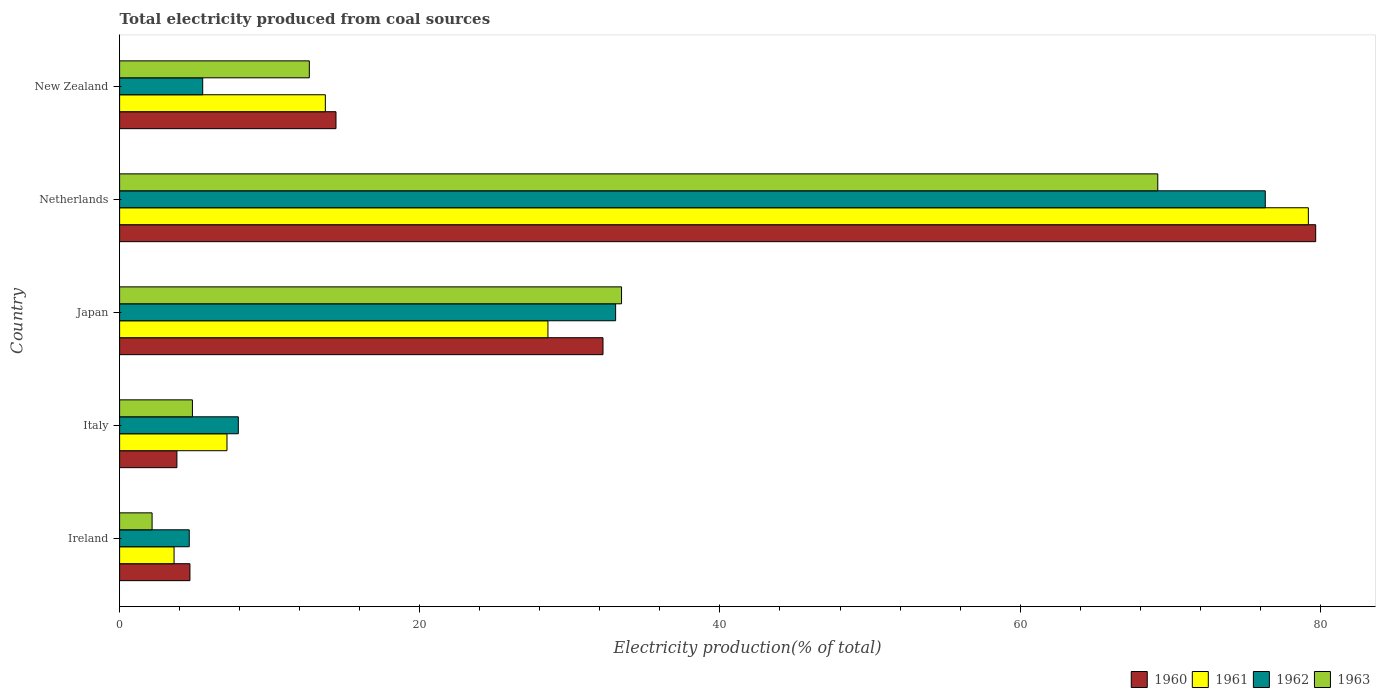How many different coloured bars are there?
Keep it short and to the point. 4. How many groups of bars are there?
Provide a short and direct response. 5. How many bars are there on the 5th tick from the top?
Provide a short and direct response. 4. How many bars are there on the 2nd tick from the bottom?
Offer a terse response. 4. What is the label of the 1st group of bars from the top?
Offer a terse response. New Zealand. In how many cases, is the number of bars for a given country not equal to the number of legend labels?
Ensure brevity in your answer.  0. What is the total electricity produced in 1960 in Ireland?
Your answer should be compact. 4.69. Across all countries, what is the maximum total electricity produced in 1961?
Ensure brevity in your answer.  79.2. Across all countries, what is the minimum total electricity produced in 1961?
Make the answer very short. 3.63. In which country was the total electricity produced in 1960 minimum?
Your answer should be very brief. Italy. What is the total total electricity produced in 1963 in the graph?
Your answer should be very brief. 122.27. What is the difference between the total electricity produced in 1960 in Ireland and that in New Zealand?
Keep it short and to the point. -9.73. What is the difference between the total electricity produced in 1963 in Italy and the total electricity produced in 1960 in New Zealand?
Give a very brief answer. -9.56. What is the average total electricity produced in 1963 per country?
Offer a terse response. 24.45. What is the difference between the total electricity produced in 1960 and total electricity produced in 1962 in Ireland?
Give a very brief answer. 0.05. In how many countries, is the total electricity produced in 1962 greater than 12 %?
Offer a terse response. 2. What is the ratio of the total electricity produced in 1962 in Italy to that in New Zealand?
Your response must be concise. 1.43. Is the difference between the total electricity produced in 1960 in Ireland and Italy greater than the difference between the total electricity produced in 1962 in Ireland and Italy?
Your answer should be compact. Yes. What is the difference between the highest and the second highest total electricity produced in 1960?
Provide a short and direct response. 47.48. What is the difference between the highest and the lowest total electricity produced in 1962?
Your answer should be compact. 71.69. Is the sum of the total electricity produced in 1963 in Ireland and New Zealand greater than the maximum total electricity produced in 1960 across all countries?
Your response must be concise. No. Is it the case that in every country, the sum of the total electricity produced in 1961 and total electricity produced in 1963 is greater than the sum of total electricity produced in 1960 and total electricity produced in 1962?
Provide a succinct answer. No. Is it the case that in every country, the sum of the total electricity produced in 1962 and total electricity produced in 1960 is greater than the total electricity produced in 1963?
Make the answer very short. Yes. Are all the bars in the graph horizontal?
Give a very brief answer. Yes. Are the values on the major ticks of X-axis written in scientific E-notation?
Your answer should be very brief. No. How are the legend labels stacked?
Offer a terse response. Horizontal. What is the title of the graph?
Provide a short and direct response. Total electricity produced from coal sources. Does "1997" appear as one of the legend labels in the graph?
Your answer should be very brief. No. What is the label or title of the X-axis?
Your answer should be very brief. Electricity production(% of total). What is the Electricity production(% of total) of 1960 in Ireland?
Offer a terse response. 4.69. What is the Electricity production(% of total) of 1961 in Ireland?
Your response must be concise. 3.63. What is the Electricity production(% of total) of 1962 in Ireland?
Offer a very short reply. 4.64. What is the Electricity production(% of total) of 1963 in Ireland?
Make the answer very short. 2.16. What is the Electricity production(% of total) of 1960 in Italy?
Provide a succinct answer. 3.82. What is the Electricity production(% of total) of 1961 in Italy?
Offer a terse response. 7.15. What is the Electricity production(% of total) of 1962 in Italy?
Provide a short and direct response. 7.91. What is the Electricity production(% of total) in 1963 in Italy?
Offer a very short reply. 4.85. What is the Electricity production(% of total) of 1960 in Japan?
Offer a very short reply. 32.21. What is the Electricity production(% of total) of 1961 in Japan?
Ensure brevity in your answer.  28.54. What is the Electricity production(% of total) in 1962 in Japan?
Make the answer very short. 33.05. What is the Electricity production(% of total) of 1963 in Japan?
Provide a succinct answer. 33.44. What is the Electricity production(% of total) of 1960 in Netherlands?
Make the answer very short. 79.69. What is the Electricity production(% of total) in 1961 in Netherlands?
Your response must be concise. 79.2. What is the Electricity production(% of total) of 1962 in Netherlands?
Ensure brevity in your answer.  76.33. What is the Electricity production(% of total) in 1963 in Netherlands?
Make the answer very short. 69.17. What is the Electricity production(% of total) of 1960 in New Zealand?
Offer a very short reply. 14.42. What is the Electricity production(% of total) in 1961 in New Zealand?
Your answer should be very brief. 13.71. What is the Electricity production(% of total) of 1962 in New Zealand?
Offer a terse response. 5.54. What is the Electricity production(% of total) in 1963 in New Zealand?
Your answer should be very brief. 12.64. Across all countries, what is the maximum Electricity production(% of total) in 1960?
Provide a succinct answer. 79.69. Across all countries, what is the maximum Electricity production(% of total) of 1961?
Your answer should be compact. 79.2. Across all countries, what is the maximum Electricity production(% of total) in 1962?
Provide a short and direct response. 76.33. Across all countries, what is the maximum Electricity production(% of total) in 1963?
Offer a very short reply. 69.17. Across all countries, what is the minimum Electricity production(% of total) of 1960?
Provide a succinct answer. 3.82. Across all countries, what is the minimum Electricity production(% of total) in 1961?
Keep it short and to the point. 3.63. Across all countries, what is the minimum Electricity production(% of total) in 1962?
Your answer should be very brief. 4.64. Across all countries, what is the minimum Electricity production(% of total) in 1963?
Offer a very short reply. 2.16. What is the total Electricity production(% of total) of 1960 in the graph?
Your answer should be compact. 134.82. What is the total Electricity production(% of total) of 1961 in the graph?
Your answer should be compact. 132.23. What is the total Electricity production(% of total) in 1962 in the graph?
Offer a terse response. 127.47. What is the total Electricity production(% of total) in 1963 in the graph?
Your response must be concise. 122.27. What is the difference between the Electricity production(% of total) of 1960 in Ireland and that in Italy?
Your response must be concise. 0.87. What is the difference between the Electricity production(% of total) of 1961 in Ireland and that in Italy?
Keep it short and to the point. -3.53. What is the difference between the Electricity production(% of total) of 1962 in Ireland and that in Italy?
Ensure brevity in your answer.  -3.27. What is the difference between the Electricity production(% of total) of 1963 in Ireland and that in Italy?
Ensure brevity in your answer.  -2.69. What is the difference between the Electricity production(% of total) of 1960 in Ireland and that in Japan?
Your answer should be very brief. -27.52. What is the difference between the Electricity production(% of total) in 1961 in Ireland and that in Japan?
Ensure brevity in your answer.  -24.91. What is the difference between the Electricity production(% of total) in 1962 in Ireland and that in Japan?
Keep it short and to the point. -28.41. What is the difference between the Electricity production(% of total) of 1963 in Ireland and that in Japan?
Give a very brief answer. -31.28. What is the difference between the Electricity production(% of total) in 1960 in Ireland and that in Netherlands?
Offer a terse response. -75.01. What is the difference between the Electricity production(% of total) of 1961 in Ireland and that in Netherlands?
Provide a short and direct response. -75.58. What is the difference between the Electricity production(% of total) in 1962 in Ireland and that in Netherlands?
Your response must be concise. -71.69. What is the difference between the Electricity production(% of total) of 1963 in Ireland and that in Netherlands?
Your response must be concise. -67.01. What is the difference between the Electricity production(% of total) of 1960 in Ireland and that in New Zealand?
Make the answer very short. -9.73. What is the difference between the Electricity production(% of total) of 1961 in Ireland and that in New Zealand?
Give a very brief answer. -10.08. What is the difference between the Electricity production(% of total) in 1962 in Ireland and that in New Zealand?
Give a very brief answer. -0.9. What is the difference between the Electricity production(% of total) in 1963 in Ireland and that in New Zealand?
Your response must be concise. -10.48. What is the difference between the Electricity production(% of total) in 1960 in Italy and that in Japan?
Provide a short and direct response. -28.39. What is the difference between the Electricity production(% of total) of 1961 in Italy and that in Japan?
Ensure brevity in your answer.  -21.38. What is the difference between the Electricity production(% of total) in 1962 in Italy and that in Japan?
Your response must be concise. -25.14. What is the difference between the Electricity production(% of total) of 1963 in Italy and that in Japan?
Keep it short and to the point. -28.59. What is the difference between the Electricity production(% of total) of 1960 in Italy and that in Netherlands?
Make the answer very short. -75.87. What is the difference between the Electricity production(% of total) in 1961 in Italy and that in Netherlands?
Your response must be concise. -72.05. What is the difference between the Electricity production(% of total) of 1962 in Italy and that in Netherlands?
Give a very brief answer. -68.42. What is the difference between the Electricity production(% of total) in 1963 in Italy and that in Netherlands?
Offer a terse response. -64.32. What is the difference between the Electricity production(% of total) of 1960 in Italy and that in New Zealand?
Your response must be concise. -10.6. What is the difference between the Electricity production(% of total) of 1961 in Italy and that in New Zealand?
Offer a very short reply. -6.55. What is the difference between the Electricity production(% of total) in 1962 in Italy and that in New Zealand?
Give a very brief answer. 2.37. What is the difference between the Electricity production(% of total) in 1963 in Italy and that in New Zealand?
Offer a terse response. -7.79. What is the difference between the Electricity production(% of total) in 1960 in Japan and that in Netherlands?
Offer a terse response. -47.48. What is the difference between the Electricity production(% of total) in 1961 in Japan and that in Netherlands?
Give a very brief answer. -50.67. What is the difference between the Electricity production(% of total) in 1962 in Japan and that in Netherlands?
Make the answer very short. -43.28. What is the difference between the Electricity production(% of total) of 1963 in Japan and that in Netherlands?
Provide a short and direct response. -35.73. What is the difference between the Electricity production(% of total) in 1960 in Japan and that in New Zealand?
Provide a succinct answer. 17.79. What is the difference between the Electricity production(% of total) of 1961 in Japan and that in New Zealand?
Keep it short and to the point. 14.83. What is the difference between the Electricity production(% of total) of 1962 in Japan and that in New Zealand?
Give a very brief answer. 27.51. What is the difference between the Electricity production(% of total) in 1963 in Japan and that in New Zealand?
Offer a very short reply. 20.8. What is the difference between the Electricity production(% of total) of 1960 in Netherlands and that in New Zealand?
Your answer should be very brief. 65.28. What is the difference between the Electricity production(% of total) of 1961 in Netherlands and that in New Zealand?
Your response must be concise. 65.5. What is the difference between the Electricity production(% of total) in 1962 in Netherlands and that in New Zealand?
Your response must be concise. 70.8. What is the difference between the Electricity production(% of total) in 1963 in Netherlands and that in New Zealand?
Give a very brief answer. 56.53. What is the difference between the Electricity production(% of total) in 1960 in Ireland and the Electricity production(% of total) in 1961 in Italy?
Your response must be concise. -2.47. What is the difference between the Electricity production(% of total) of 1960 in Ireland and the Electricity production(% of total) of 1962 in Italy?
Give a very brief answer. -3.22. What is the difference between the Electricity production(% of total) in 1960 in Ireland and the Electricity production(% of total) in 1963 in Italy?
Offer a terse response. -0.17. What is the difference between the Electricity production(% of total) of 1961 in Ireland and the Electricity production(% of total) of 1962 in Italy?
Provide a succinct answer. -4.28. What is the difference between the Electricity production(% of total) in 1961 in Ireland and the Electricity production(% of total) in 1963 in Italy?
Provide a short and direct response. -1.22. What is the difference between the Electricity production(% of total) in 1962 in Ireland and the Electricity production(% of total) in 1963 in Italy?
Your answer should be very brief. -0.21. What is the difference between the Electricity production(% of total) of 1960 in Ireland and the Electricity production(% of total) of 1961 in Japan?
Your answer should be very brief. -23.85. What is the difference between the Electricity production(% of total) of 1960 in Ireland and the Electricity production(% of total) of 1962 in Japan?
Offer a terse response. -28.36. What is the difference between the Electricity production(% of total) of 1960 in Ireland and the Electricity production(% of total) of 1963 in Japan?
Give a very brief answer. -28.76. What is the difference between the Electricity production(% of total) in 1961 in Ireland and the Electricity production(% of total) in 1962 in Japan?
Ensure brevity in your answer.  -29.42. What is the difference between the Electricity production(% of total) in 1961 in Ireland and the Electricity production(% of total) in 1963 in Japan?
Offer a terse response. -29.82. What is the difference between the Electricity production(% of total) of 1962 in Ireland and the Electricity production(% of total) of 1963 in Japan?
Make the answer very short. -28.8. What is the difference between the Electricity production(% of total) of 1960 in Ireland and the Electricity production(% of total) of 1961 in Netherlands?
Offer a very short reply. -74.52. What is the difference between the Electricity production(% of total) of 1960 in Ireland and the Electricity production(% of total) of 1962 in Netherlands?
Provide a succinct answer. -71.65. What is the difference between the Electricity production(% of total) in 1960 in Ireland and the Electricity production(% of total) in 1963 in Netherlands?
Ensure brevity in your answer.  -64.49. What is the difference between the Electricity production(% of total) in 1961 in Ireland and the Electricity production(% of total) in 1962 in Netherlands?
Your answer should be compact. -72.71. What is the difference between the Electricity production(% of total) of 1961 in Ireland and the Electricity production(% of total) of 1963 in Netherlands?
Ensure brevity in your answer.  -65.54. What is the difference between the Electricity production(% of total) in 1962 in Ireland and the Electricity production(% of total) in 1963 in Netherlands?
Provide a short and direct response. -64.53. What is the difference between the Electricity production(% of total) of 1960 in Ireland and the Electricity production(% of total) of 1961 in New Zealand?
Make the answer very short. -9.02. What is the difference between the Electricity production(% of total) of 1960 in Ireland and the Electricity production(% of total) of 1962 in New Zealand?
Offer a very short reply. -0.85. What is the difference between the Electricity production(% of total) of 1960 in Ireland and the Electricity production(% of total) of 1963 in New Zealand?
Give a very brief answer. -7.95. What is the difference between the Electricity production(% of total) in 1961 in Ireland and the Electricity production(% of total) in 1962 in New Zealand?
Ensure brevity in your answer.  -1.91. What is the difference between the Electricity production(% of total) in 1961 in Ireland and the Electricity production(% of total) in 1963 in New Zealand?
Make the answer very short. -9.01. What is the difference between the Electricity production(% of total) of 1962 in Ireland and the Electricity production(% of total) of 1963 in New Zealand?
Your response must be concise. -8. What is the difference between the Electricity production(% of total) of 1960 in Italy and the Electricity production(% of total) of 1961 in Japan?
Ensure brevity in your answer.  -24.72. What is the difference between the Electricity production(% of total) in 1960 in Italy and the Electricity production(% of total) in 1962 in Japan?
Your response must be concise. -29.23. What is the difference between the Electricity production(% of total) of 1960 in Italy and the Electricity production(% of total) of 1963 in Japan?
Provide a short and direct response. -29.63. What is the difference between the Electricity production(% of total) of 1961 in Italy and the Electricity production(% of total) of 1962 in Japan?
Make the answer very short. -25.89. What is the difference between the Electricity production(% of total) of 1961 in Italy and the Electricity production(% of total) of 1963 in Japan?
Your answer should be very brief. -26.29. What is the difference between the Electricity production(% of total) of 1962 in Italy and the Electricity production(% of total) of 1963 in Japan?
Provide a short and direct response. -25.53. What is the difference between the Electricity production(% of total) in 1960 in Italy and the Electricity production(% of total) in 1961 in Netherlands?
Provide a succinct answer. -75.39. What is the difference between the Electricity production(% of total) in 1960 in Italy and the Electricity production(% of total) in 1962 in Netherlands?
Your answer should be very brief. -72.51. What is the difference between the Electricity production(% of total) of 1960 in Italy and the Electricity production(% of total) of 1963 in Netherlands?
Offer a terse response. -65.35. What is the difference between the Electricity production(% of total) in 1961 in Italy and the Electricity production(% of total) in 1962 in Netherlands?
Your answer should be very brief. -69.18. What is the difference between the Electricity production(% of total) in 1961 in Italy and the Electricity production(% of total) in 1963 in Netherlands?
Make the answer very short. -62.02. What is the difference between the Electricity production(% of total) in 1962 in Italy and the Electricity production(% of total) in 1963 in Netherlands?
Make the answer very short. -61.26. What is the difference between the Electricity production(% of total) in 1960 in Italy and the Electricity production(% of total) in 1961 in New Zealand?
Provide a short and direct response. -9.89. What is the difference between the Electricity production(% of total) in 1960 in Italy and the Electricity production(% of total) in 1962 in New Zealand?
Offer a terse response. -1.72. What is the difference between the Electricity production(% of total) of 1960 in Italy and the Electricity production(% of total) of 1963 in New Zealand?
Ensure brevity in your answer.  -8.82. What is the difference between the Electricity production(% of total) of 1961 in Italy and the Electricity production(% of total) of 1962 in New Zealand?
Provide a short and direct response. 1.62. What is the difference between the Electricity production(% of total) of 1961 in Italy and the Electricity production(% of total) of 1963 in New Zealand?
Make the answer very short. -5.49. What is the difference between the Electricity production(% of total) of 1962 in Italy and the Electricity production(% of total) of 1963 in New Zealand?
Your response must be concise. -4.73. What is the difference between the Electricity production(% of total) in 1960 in Japan and the Electricity production(% of total) in 1961 in Netherlands?
Your answer should be compact. -47. What is the difference between the Electricity production(% of total) of 1960 in Japan and the Electricity production(% of total) of 1962 in Netherlands?
Make the answer very short. -44.13. What is the difference between the Electricity production(% of total) of 1960 in Japan and the Electricity production(% of total) of 1963 in Netherlands?
Your response must be concise. -36.96. What is the difference between the Electricity production(% of total) in 1961 in Japan and the Electricity production(% of total) in 1962 in Netherlands?
Your answer should be very brief. -47.79. What is the difference between the Electricity production(% of total) of 1961 in Japan and the Electricity production(% of total) of 1963 in Netherlands?
Your answer should be compact. -40.63. What is the difference between the Electricity production(% of total) of 1962 in Japan and the Electricity production(% of total) of 1963 in Netherlands?
Provide a succinct answer. -36.12. What is the difference between the Electricity production(% of total) of 1960 in Japan and the Electricity production(% of total) of 1961 in New Zealand?
Keep it short and to the point. 18.5. What is the difference between the Electricity production(% of total) of 1960 in Japan and the Electricity production(% of total) of 1962 in New Zealand?
Your answer should be compact. 26.67. What is the difference between the Electricity production(% of total) of 1960 in Japan and the Electricity production(% of total) of 1963 in New Zealand?
Provide a short and direct response. 19.57. What is the difference between the Electricity production(% of total) of 1961 in Japan and the Electricity production(% of total) of 1962 in New Zealand?
Your response must be concise. 23. What is the difference between the Electricity production(% of total) in 1961 in Japan and the Electricity production(% of total) in 1963 in New Zealand?
Ensure brevity in your answer.  15.9. What is the difference between the Electricity production(% of total) of 1962 in Japan and the Electricity production(% of total) of 1963 in New Zealand?
Make the answer very short. 20.41. What is the difference between the Electricity production(% of total) of 1960 in Netherlands and the Electricity production(% of total) of 1961 in New Zealand?
Give a very brief answer. 65.98. What is the difference between the Electricity production(% of total) in 1960 in Netherlands and the Electricity production(% of total) in 1962 in New Zealand?
Your response must be concise. 74.16. What is the difference between the Electricity production(% of total) of 1960 in Netherlands and the Electricity production(% of total) of 1963 in New Zealand?
Keep it short and to the point. 67.05. What is the difference between the Electricity production(% of total) in 1961 in Netherlands and the Electricity production(% of total) in 1962 in New Zealand?
Your answer should be very brief. 73.67. What is the difference between the Electricity production(% of total) of 1961 in Netherlands and the Electricity production(% of total) of 1963 in New Zealand?
Your answer should be compact. 66.56. What is the difference between the Electricity production(% of total) in 1962 in Netherlands and the Electricity production(% of total) in 1963 in New Zealand?
Provide a succinct answer. 63.69. What is the average Electricity production(% of total) of 1960 per country?
Keep it short and to the point. 26.96. What is the average Electricity production(% of total) of 1961 per country?
Ensure brevity in your answer.  26.45. What is the average Electricity production(% of total) of 1962 per country?
Your answer should be very brief. 25.49. What is the average Electricity production(% of total) of 1963 per country?
Your answer should be compact. 24.45. What is the difference between the Electricity production(% of total) of 1960 and Electricity production(% of total) of 1961 in Ireland?
Your response must be concise. 1.06. What is the difference between the Electricity production(% of total) in 1960 and Electricity production(% of total) in 1962 in Ireland?
Your answer should be very brief. 0.05. What is the difference between the Electricity production(% of total) of 1960 and Electricity production(% of total) of 1963 in Ireland?
Provide a short and direct response. 2.52. What is the difference between the Electricity production(% of total) of 1961 and Electricity production(% of total) of 1962 in Ireland?
Provide a succinct answer. -1.01. What is the difference between the Electricity production(% of total) of 1961 and Electricity production(% of total) of 1963 in Ireland?
Provide a succinct answer. 1.46. What is the difference between the Electricity production(% of total) of 1962 and Electricity production(% of total) of 1963 in Ireland?
Give a very brief answer. 2.48. What is the difference between the Electricity production(% of total) of 1960 and Electricity production(% of total) of 1961 in Italy?
Provide a succinct answer. -3.34. What is the difference between the Electricity production(% of total) of 1960 and Electricity production(% of total) of 1962 in Italy?
Keep it short and to the point. -4.09. What is the difference between the Electricity production(% of total) of 1960 and Electricity production(% of total) of 1963 in Italy?
Your answer should be very brief. -1.03. What is the difference between the Electricity production(% of total) of 1961 and Electricity production(% of total) of 1962 in Italy?
Keep it short and to the point. -0.75. What is the difference between the Electricity production(% of total) in 1961 and Electricity production(% of total) in 1963 in Italy?
Ensure brevity in your answer.  2.3. What is the difference between the Electricity production(% of total) in 1962 and Electricity production(% of total) in 1963 in Italy?
Make the answer very short. 3.06. What is the difference between the Electricity production(% of total) of 1960 and Electricity production(% of total) of 1961 in Japan?
Offer a terse response. 3.67. What is the difference between the Electricity production(% of total) in 1960 and Electricity production(% of total) in 1962 in Japan?
Offer a very short reply. -0.84. What is the difference between the Electricity production(% of total) of 1960 and Electricity production(% of total) of 1963 in Japan?
Provide a succinct answer. -1.24. What is the difference between the Electricity production(% of total) in 1961 and Electricity production(% of total) in 1962 in Japan?
Your response must be concise. -4.51. What is the difference between the Electricity production(% of total) of 1961 and Electricity production(% of total) of 1963 in Japan?
Make the answer very short. -4.9. What is the difference between the Electricity production(% of total) in 1962 and Electricity production(% of total) in 1963 in Japan?
Your response must be concise. -0.4. What is the difference between the Electricity production(% of total) in 1960 and Electricity production(% of total) in 1961 in Netherlands?
Make the answer very short. 0.49. What is the difference between the Electricity production(% of total) in 1960 and Electricity production(% of total) in 1962 in Netherlands?
Provide a short and direct response. 3.36. What is the difference between the Electricity production(% of total) in 1960 and Electricity production(% of total) in 1963 in Netherlands?
Offer a terse response. 10.52. What is the difference between the Electricity production(% of total) of 1961 and Electricity production(% of total) of 1962 in Netherlands?
Provide a succinct answer. 2.87. What is the difference between the Electricity production(% of total) in 1961 and Electricity production(% of total) in 1963 in Netherlands?
Make the answer very short. 10.03. What is the difference between the Electricity production(% of total) of 1962 and Electricity production(% of total) of 1963 in Netherlands?
Provide a succinct answer. 7.16. What is the difference between the Electricity production(% of total) of 1960 and Electricity production(% of total) of 1961 in New Zealand?
Your response must be concise. 0.71. What is the difference between the Electricity production(% of total) in 1960 and Electricity production(% of total) in 1962 in New Zealand?
Provide a succinct answer. 8.88. What is the difference between the Electricity production(% of total) in 1960 and Electricity production(% of total) in 1963 in New Zealand?
Your answer should be very brief. 1.78. What is the difference between the Electricity production(% of total) of 1961 and Electricity production(% of total) of 1962 in New Zealand?
Ensure brevity in your answer.  8.17. What is the difference between the Electricity production(% of total) of 1961 and Electricity production(% of total) of 1963 in New Zealand?
Provide a short and direct response. 1.07. What is the difference between the Electricity production(% of total) of 1962 and Electricity production(% of total) of 1963 in New Zealand?
Your answer should be compact. -7.1. What is the ratio of the Electricity production(% of total) of 1960 in Ireland to that in Italy?
Keep it short and to the point. 1.23. What is the ratio of the Electricity production(% of total) in 1961 in Ireland to that in Italy?
Give a very brief answer. 0.51. What is the ratio of the Electricity production(% of total) of 1962 in Ireland to that in Italy?
Your answer should be compact. 0.59. What is the ratio of the Electricity production(% of total) of 1963 in Ireland to that in Italy?
Give a very brief answer. 0.45. What is the ratio of the Electricity production(% of total) in 1960 in Ireland to that in Japan?
Give a very brief answer. 0.15. What is the ratio of the Electricity production(% of total) in 1961 in Ireland to that in Japan?
Provide a short and direct response. 0.13. What is the ratio of the Electricity production(% of total) of 1962 in Ireland to that in Japan?
Your answer should be compact. 0.14. What is the ratio of the Electricity production(% of total) in 1963 in Ireland to that in Japan?
Give a very brief answer. 0.06. What is the ratio of the Electricity production(% of total) in 1960 in Ireland to that in Netherlands?
Provide a short and direct response. 0.06. What is the ratio of the Electricity production(% of total) in 1961 in Ireland to that in Netherlands?
Offer a very short reply. 0.05. What is the ratio of the Electricity production(% of total) of 1962 in Ireland to that in Netherlands?
Your response must be concise. 0.06. What is the ratio of the Electricity production(% of total) of 1963 in Ireland to that in Netherlands?
Your answer should be very brief. 0.03. What is the ratio of the Electricity production(% of total) in 1960 in Ireland to that in New Zealand?
Provide a short and direct response. 0.33. What is the ratio of the Electricity production(% of total) in 1961 in Ireland to that in New Zealand?
Give a very brief answer. 0.26. What is the ratio of the Electricity production(% of total) in 1962 in Ireland to that in New Zealand?
Offer a very short reply. 0.84. What is the ratio of the Electricity production(% of total) of 1963 in Ireland to that in New Zealand?
Keep it short and to the point. 0.17. What is the ratio of the Electricity production(% of total) in 1960 in Italy to that in Japan?
Your answer should be very brief. 0.12. What is the ratio of the Electricity production(% of total) of 1961 in Italy to that in Japan?
Offer a very short reply. 0.25. What is the ratio of the Electricity production(% of total) in 1962 in Italy to that in Japan?
Keep it short and to the point. 0.24. What is the ratio of the Electricity production(% of total) in 1963 in Italy to that in Japan?
Provide a succinct answer. 0.15. What is the ratio of the Electricity production(% of total) of 1960 in Italy to that in Netherlands?
Provide a short and direct response. 0.05. What is the ratio of the Electricity production(% of total) of 1961 in Italy to that in Netherlands?
Provide a short and direct response. 0.09. What is the ratio of the Electricity production(% of total) of 1962 in Italy to that in Netherlands?
Your response must be concise. 0.1. What is the ratio of the Electricity production(% of total) in 1963 in Italy to that in Netherlands?
Keep it short and to the point. 0.07. What is the ratio of the Electricity production(% of total) in 1960 in Italy to that in New Zealand?
Make the answer very short. 0.26. What is the ratio of the Electricity production(% of total) in 1961 in Italy to that in New Zealand?
Give a very brief answer. 0.52. What is the ratio of the Electricity production(% of total) in 1962 in Italy to that in New Zealand?
Offer a very short reply. 1.43. What is the ratio of the Electricity production(% of total) in 1963 in Italy to that in New Zealand?
Your response must be concise. 0.38. What is the ratio of the Electricity production(% of total) in 1960 in Japan to that in Netherlands?
Provide a succinct answer. 0.4. What is the ratio of the Electricity production(% of total) of 1961 in Japan to that in Netherlands?
Your answer should be compact. 0.36. What is the ratio of the Electricity production(% of total) in 1962 in Japan to that in Netherlands?
Keep it short and to the point. 0.43. What is the ratio of the Electricity production(% of total) in 1963 in Japan to that in Netherlands?
Provide a succinct answer. 0.48. What is the ratio of the Electricity production(% of total) in 1960 in Japan to that in New Zealand?
Ensure brevity in your answer.  2.23. What is the ratio of the Electricity production(% of total) of 1961 in Japan to that in New Zealand?
Provide a succinct answer. 2.08. What is the ratio of the Electricity production(% of total) of 1962 in Japan to that in New Zealand?
Make the answer very short. 5.97. What is the ratio of the Electricity production(% of total) of 1963 in Japan to that in New Zealand?
Ensure brevity in your answer.  2.65. What is the ratio of the Electricity production(% of total) in 1960 in Netherlands to that in New Zealand?
Make the answer very short. 5.53. What is the ratio of the Electricity production(% of total) of 1961 in Netherlands to that in New Zealand?
Give a very brief answer. 5.78. What is the ratio of the Electricity production(% of total) in 1962 in Netherlands to that in New Zealand?
Your response must be concise. 13.79. What is the ratio of the Electricity production(% of total) in 1963 in Netherlands to that in New Zealand?
Ensure brevity in your answer.  5.47. What is the difference between the highest and the second highest Electricity production(% of total) in 1960?
Your response must be concise. 47.48. What is the difference between the highest and the second highest Electricity production(% of total) in 1961?
Offer a very short reply. 50.67. What is the difference between the highest and the second highest Electricity production(% of total) in 1962?
Provide a succinct answer. 43.28. What is the difference between the highest and the second highest Electricity production(% of total) of 1963?
Your answer should be very brief. 35.73. What is the difference between the highest and the lowest Electricity production(% of total) in 1960?
Provide a succinct answer. 75.87. What is the difference between the highest and the lowest Electricity production(% of total) of 1961?
Keep it short and to the point. 75.58. What is the difference between the highest and the lowest Electricity production(% of total) of 1962?
Ensure brevity in your answer.  71.69. What is the difference between the highest and the lowest Electricity production(% of total) in 1963?
Your answer should be compact. 67.01. 